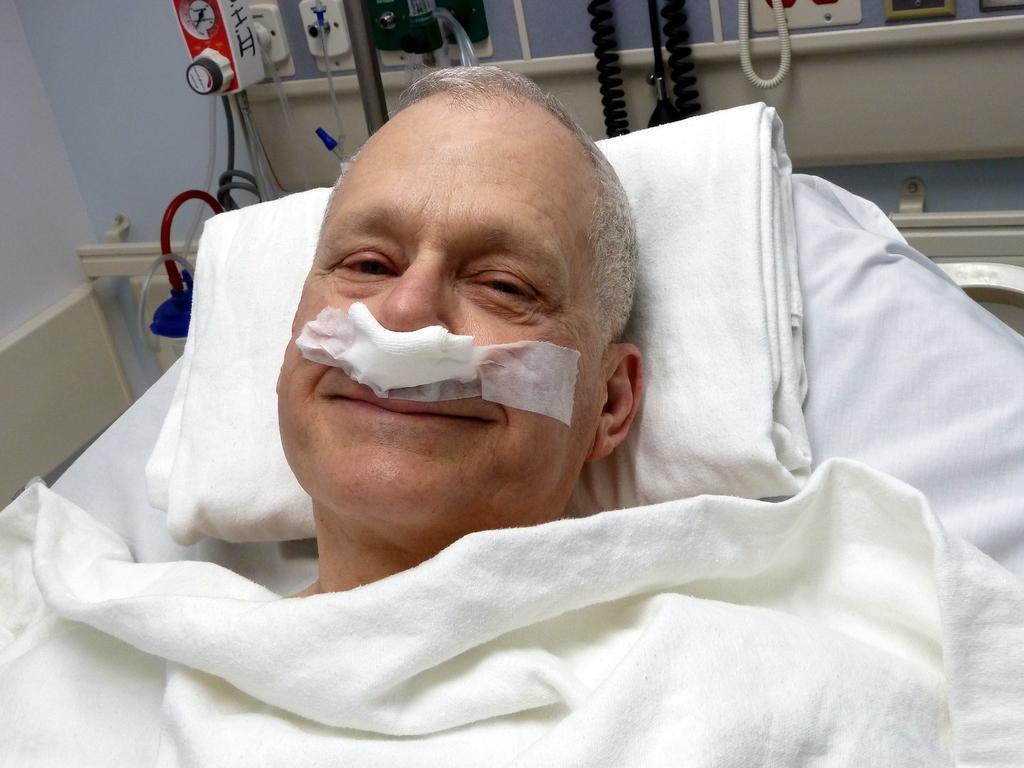How would you summarize this image in a sentence or two? In this image we can see one man lying on the bed, one pillow, two white bed sheets, one object attached to the wall on the left side of the image and in the background there are some objects attached to the wall. 